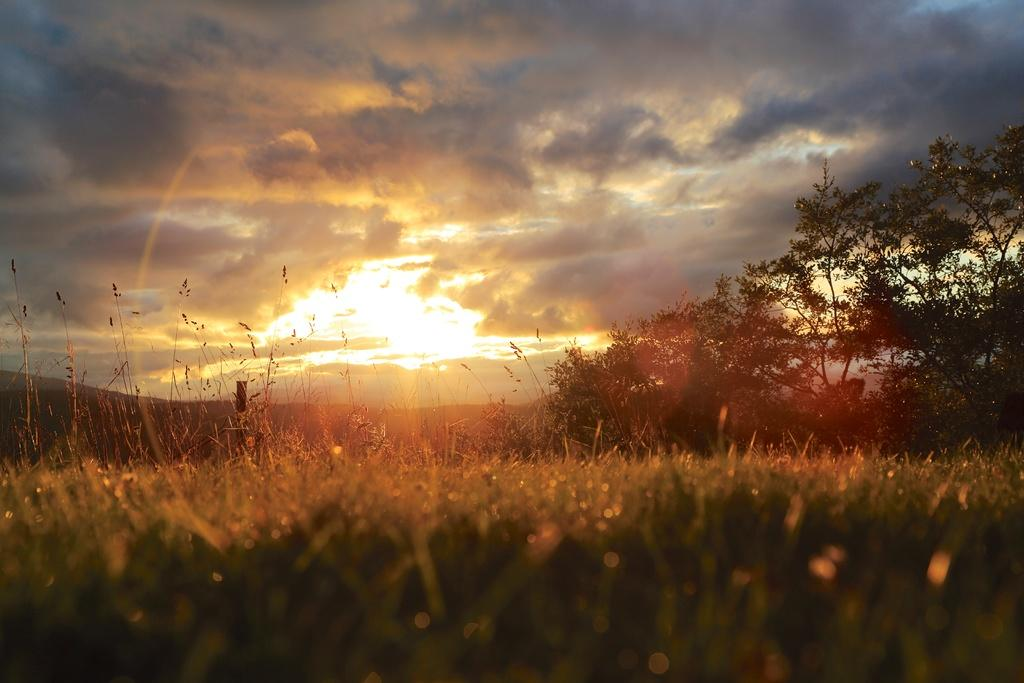What type of vegetation is at the bottom of the image? There are plants at the bottom of the image. What can be seen in the background of the image? There are trees in the background of the image. What is visible at the top of the image? The sky is visible at the top of the image. What is present in the sky? Clouds are present in the sky. Can you tell me how many toes are visible in the image? There are no toes present in the image. What type of rifle is being used by the plants in the image? There are no rifles present in the image; it features plants, trees, and clouds. 